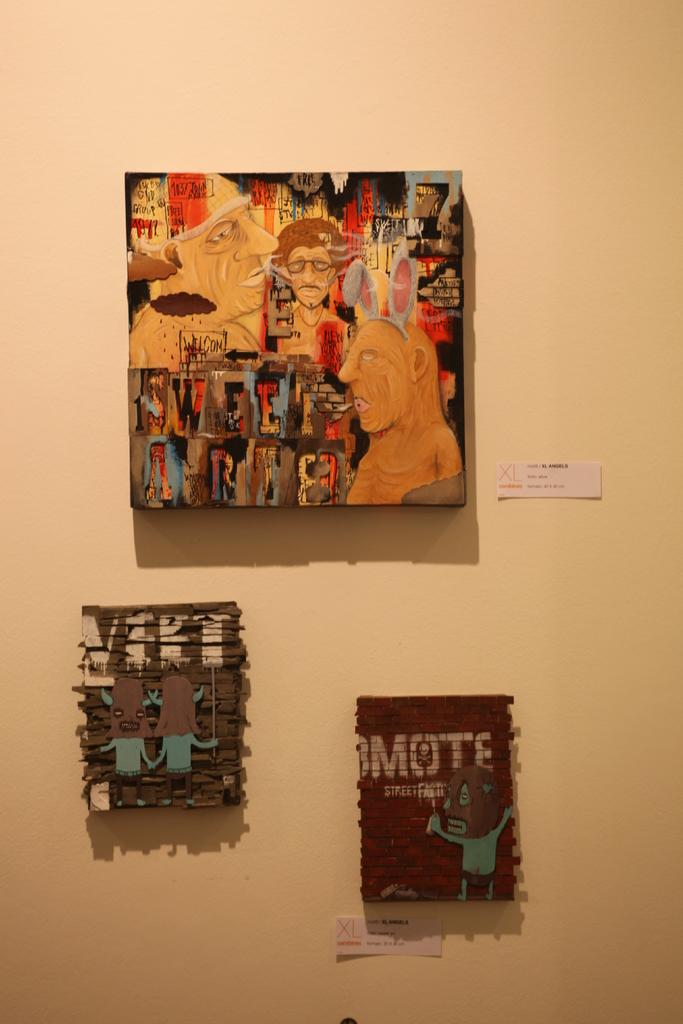What is hanging on the wall in the image? There are photo frames on the wall in the image. What is the color of the wall in the image? The wall is in cream color. What type of powder is being used for lunch in the image? There is no mention of powder or lunch in the image; it only features photo frames on a cream-colored wall. 